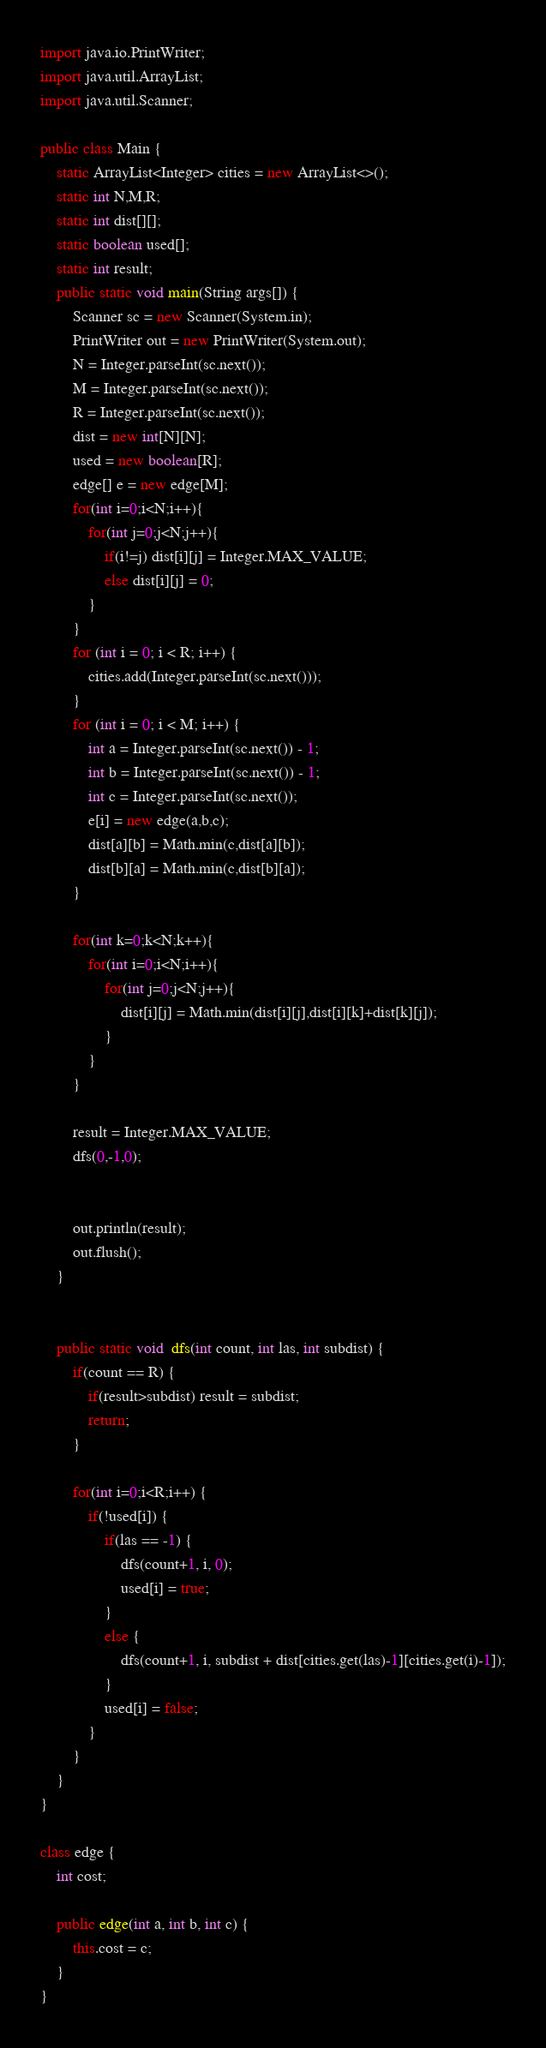<code> <loc_0><loc_0><loc_500><loc_500><_Java_>import java.io.PrintWriter;
import java.util.ArrayList;
import java.util.Scanner;

public class Main {
	static ArrayList<Integer> cities = new ArrayList<>();
	static int N,M,R;
	static int dist[][];
	static boolean used[];
	static int result;
	public static void main(String args[]) {
		Scanner sc = new Scanner(System.in);
		PrintWriter out = new PrintWriter(System.out);
		N = Integer.parseInt(sc.next());
		M = Integer.parseInt(sc.next());
		R = Integer.parseInt(sc.next());
		dist = new int[N][N];
		used = new boolean[R];
		edge[] e = new edge[M];
		for(int i=0;i<N;i++){
			for(int j=0;j<N;j++){
				if(i!=j) dist[i][j] = Integer.MAX_VALUE;
				else dist[i][j] = 0;
			}
		}
		for (int i = 0; i < R; i++) {
			cities.add(Integer.parseInt(sc.next()));
		}
		for (int i = 0; i < M; i++) {
			int a = Integer.parseInt(sc.next()) - 1;
			int b = Integer.parseInt(sc.next()) - 1;
			int c = Integer.parseInt(sc.next());
			e[i] = new edge(a,b,c);
			dist[a][b] = Math.min(c,dist[a][b]);
			dist[b][a] = Math.min(c,dist[b][a]);
		}

		for(int k=0;k<N;k++){
			for(int i=0;i<N;i++){
				for(int j=0;j<N;j++){
					dist[i][j] = Math.min(dist[i][j],dist[i][k]+dist[k][j]);
				}
			}
		}

		result = Integer.MAX_VALUE;
		dfs(0,-1,0);


		out.println(result);
		out.flush();
	}


	public static void  dfs(int count, int las, int subdist) {
		if(count == R) {
			if(result>subdist) result = subdist;
			return;
		}

		for(int i=0;i<R;i++) {
			if(!used[i]) {
				if(las == -1) {
					dfs(count+1, i, 0);
					used[i] = true;
				}
				else {
					dfs(count+1, i, subdist + dist[cities.get(las)-1][cities.get(i)-1]);
				}
				used[i] = false;
			}
		}
	}
}

class edge {
	int cost;

	public edge(int a, int b, int c) {
		this.cost = c;
	}
}</code> 